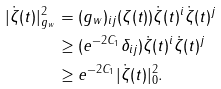<formula> <loc_0><loc_0><loc_500><loc_500>| \dot { \zeta } ( t ) | ^ { 2 } _ { g _ { w } } & = ( g _ { w } ) _ { i j } ( \zeta ( t ) ) \dot { \zeta } ( t ) ^ { i } \dot { \zeta } ( t ) ^ { j } \\ & \geq ( e ^ { - 2 C _ { 1 } } \delta _ { i j } ) \dot { \zeta } ( t ) ^ { i } \dot { \zeta } ( t ) ^ { j } \\ & \geq e ^ { - 2 C _ { 1 } } | \dot { \zeta } ( t ) | ^ { 2 } _ { 0 } .</formula> 